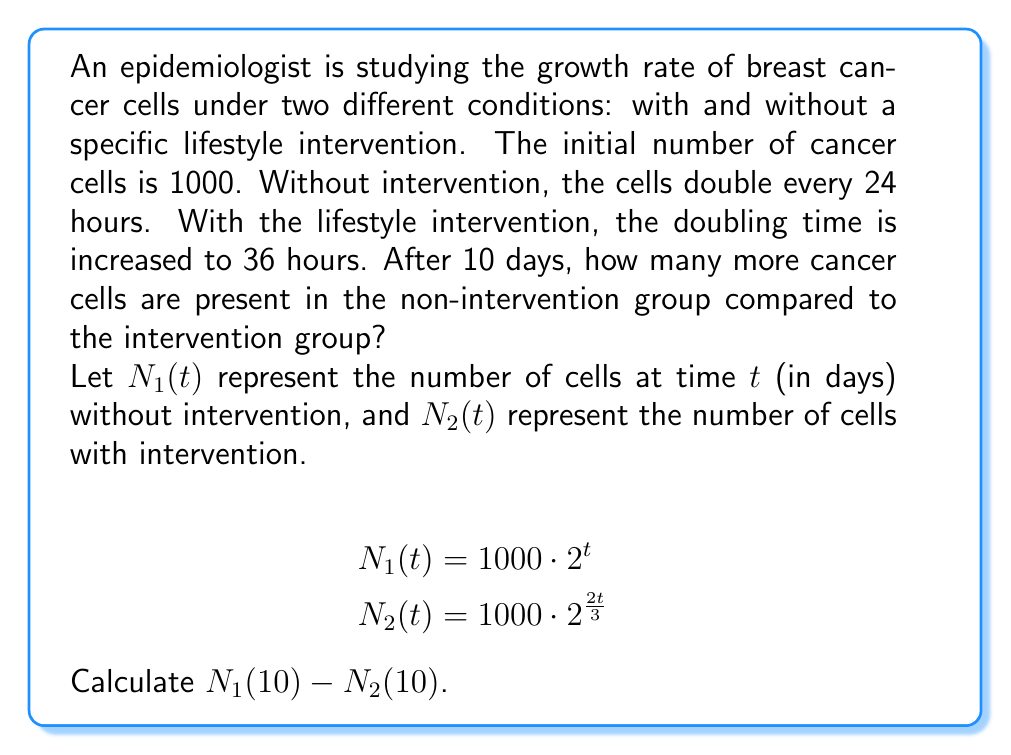Solve this math problem. To solve this problem, we need to follow these steps:

1) First, let's calculate $N_1(10)$:
   $$N_1(10) = 1000 \cdot 2^{10} = 1000 \cdot 1024 = 1,024,000$$

2) Next, let's calculate $N_2(10)$:
   $$N_2(10) = 1000 \cdot 2^{\frac{2 \cdot 10}{3}} = 1000 \cdot 2^{\frac{20}{3}}$$

3) To calculate $2^{\frac{20}{3}}$, we can use the properties of exponents:
   $$2^{\frac{20}{3}} = (2^{\frac{1}{3}})^{20} \approx 1.2599^{20} \approx 95.37$$

4) So, $N_2(10) \approx 1000 \cdot 95.37 = 95,370$

5) Now, we can calculate the difference:
   $$N_1(10) - N_2(10) = 1,024,000 - 95,370 = 928,630$$

Therefore, after 10 days, there are approximately 928,630 more cancer cells in the non-intervention group compared to the intervention group.
Answer: 928,630 cells 